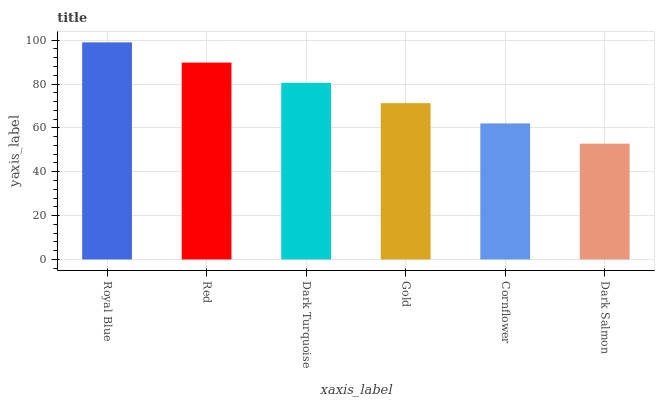Is Dark Salmon the minimum?
Answer yes or no. Yes. Is Royal Blue the maximum?
Answer yes or no. Yes. Is Red the minimum?
Answer yes or no. No. Is Red the maximum?
Answer yes or no. No. Is Royal Blue greater than Red?
Answer yes or no. Yes. Is Red less than Royal Blue?
Answer yes or no. Yes. Is Red greater than Royal Blue?
Answer yes or no. No. Is Royal Blue less than Red?
Answer yes or no. No. Is Dark Turquoise the high median?
Answer yes or no. Yes. Is Gold the low median?
Answer yes or no. Yes. Is Royal Blue the high median?
Answer yes or no. No. Is Red the low median?
Answer yes or no. No. 